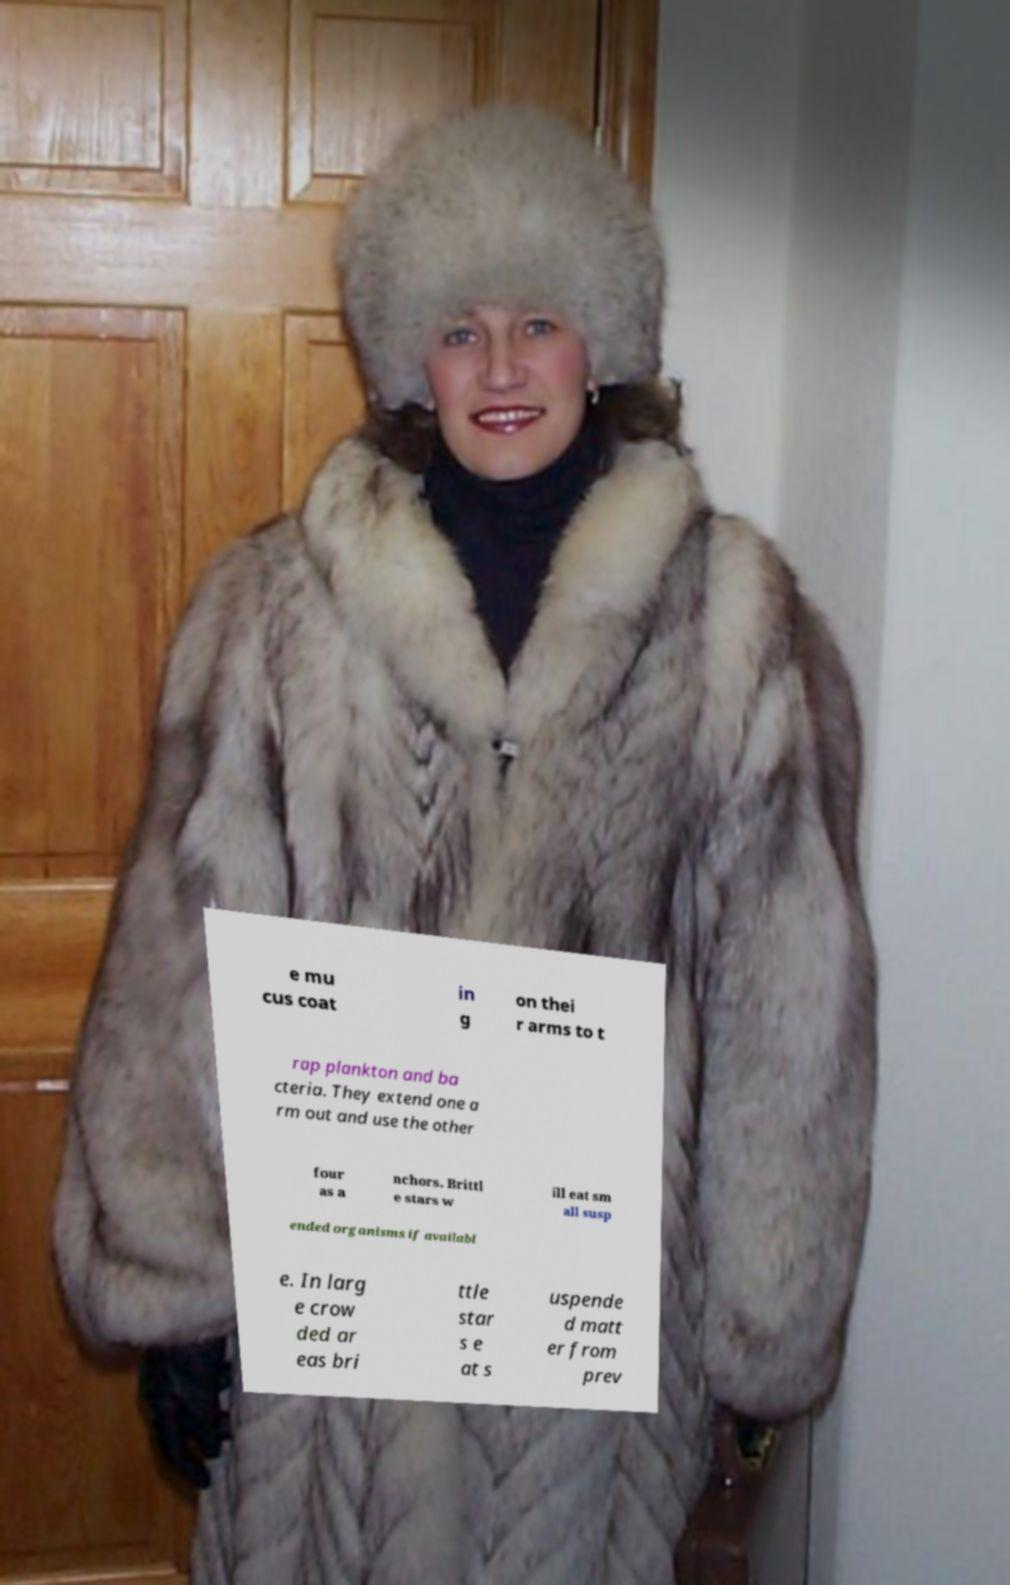Can you accurately transcribe the text from the provided image for me? e mu cus coat in g on thei r arms to t rap plankton and ba cteria. They extend one a rm out and use the other four as a nchors. Brittl e stars w ill eat sm all susp ended organisms if availabl e. In larg e crow ded ar eas bri ttle star s e at s uspende d matt er from prev 